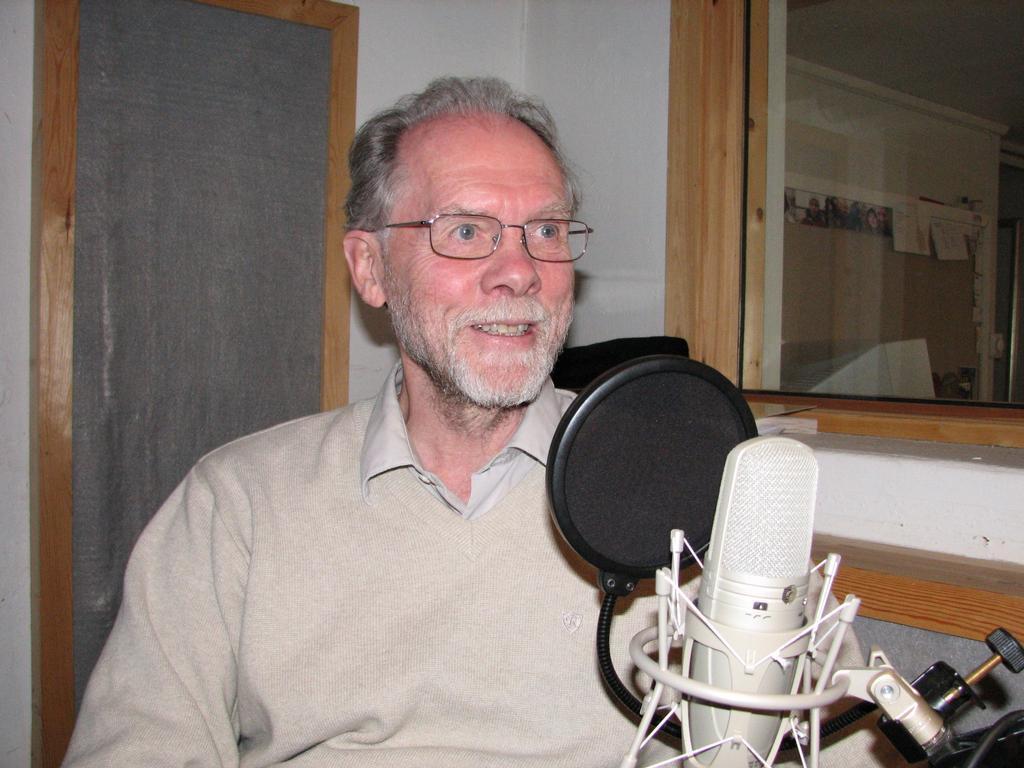Describe this image in one or two sentences. There is a person wearing specs is sitting. In front of him there is a mic. In the back there is a glass window and a wall. 